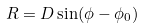<formula> <loc_0><loc_0><loc_500><loc_500>R = D \sin ( \phi - \phi _ { 0 } )</formula> 